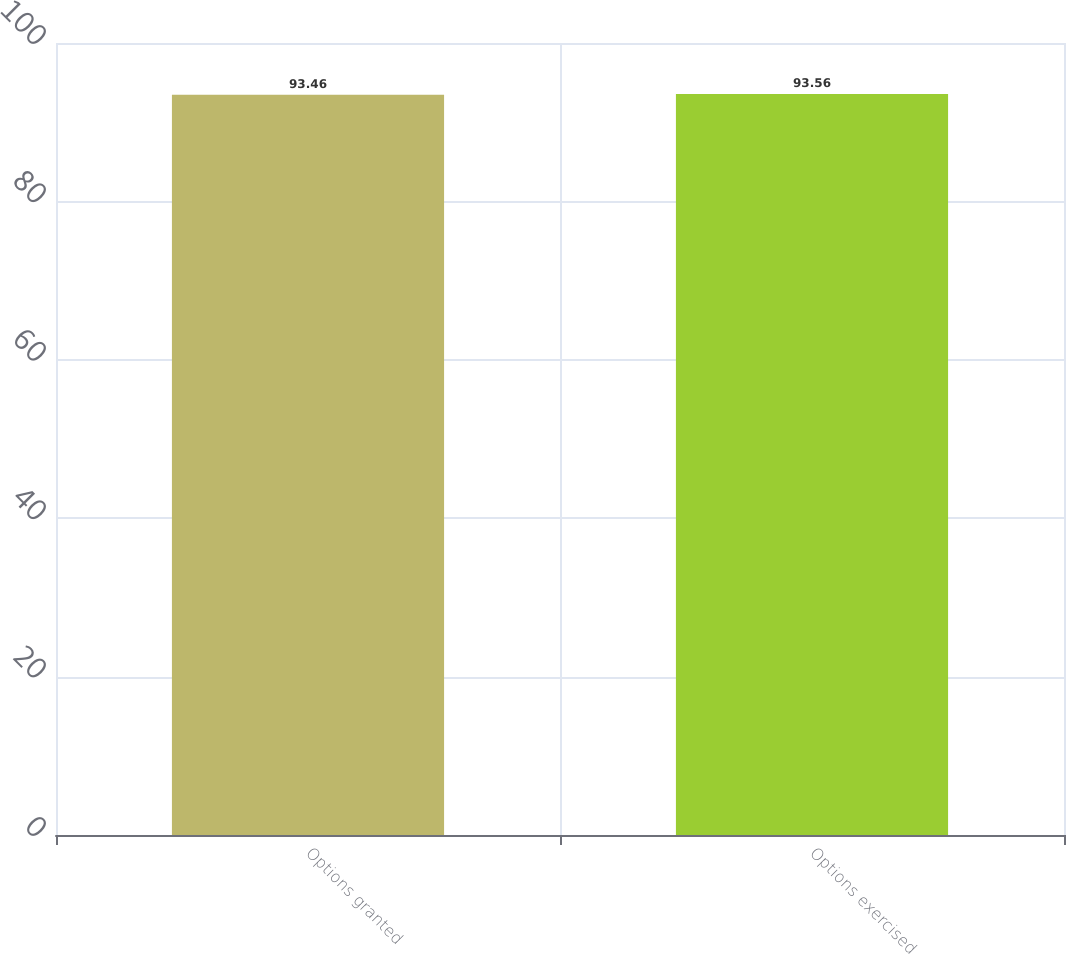<chart> <loc_0><loc_0><loc_500><loc_500><bar_chart><fcel>Options granted<fcel>Options exercised<nl><fcel>93.46<fcel>93.56<nl></chart> 